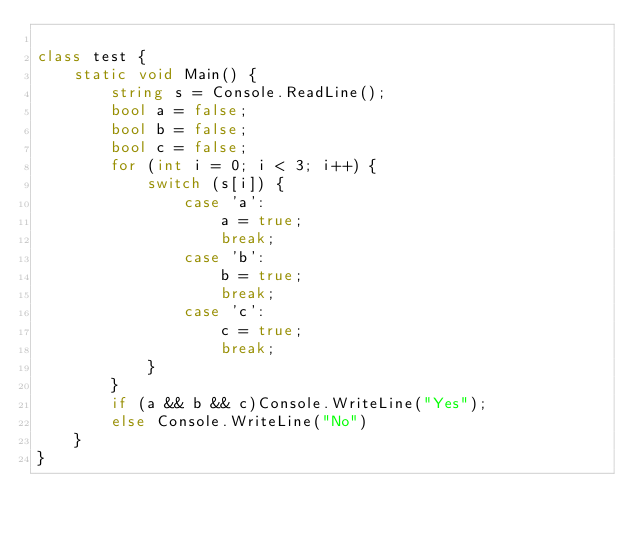<code> <loc_0><loc_0><loc_500><loc_500><_C#_>
class test {
    static void Main() {
        string s = Console.ReadLine();
        bool a = false;
        bool b = false;
        bool c = false;
        for (int i = 0; i < 3; i++) {
            switch (s[i]) {
                case 'a':
                    a = true;
                    break;
                case 'b':
                    b = true;
                    break;
                case 'c':
                    c = true;
                    break;
            }
        }
        if (a && b && c)Console.WriteLine("Yes");
        else Console.WriteLine("No")
    }
}</code> 